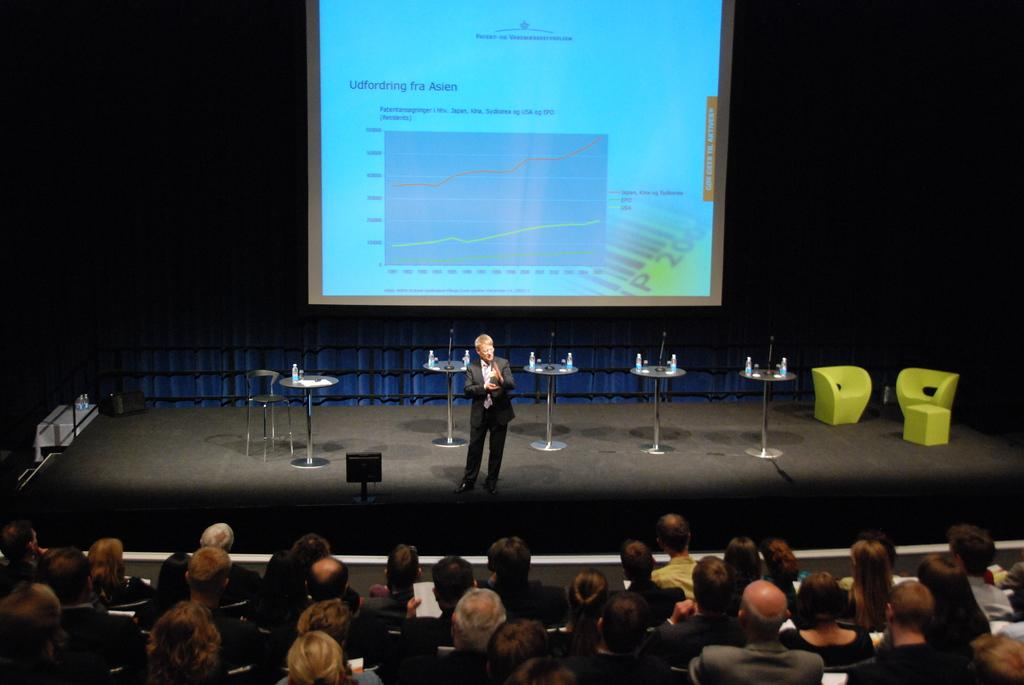What can be seen in the image involving a group of people? There is a group of people in the image. What is the person on the stage doing? The person standing on the stage is likely giving a presentation or performing. What type of furniture is present in the image? Tables and chairs are visible in the image. What type of containers are in the image? Bottles are in the image. What type of display device is present in the image? There is a screen in the image. Can you describe the unspecified objects in the image? Unfortunately, the facts provided do not specify the nature of the unspecified objects. What type of wilderness can be seen in the background of the image? There is no wilderness present in the image; it primarily features a group of people, a stage, furniture, containers, and a screen. What type of creature is interacting with the person on the stage? There is no creature present in the image; it only features a group of people, a stage, furniture, containers, and a screen. 